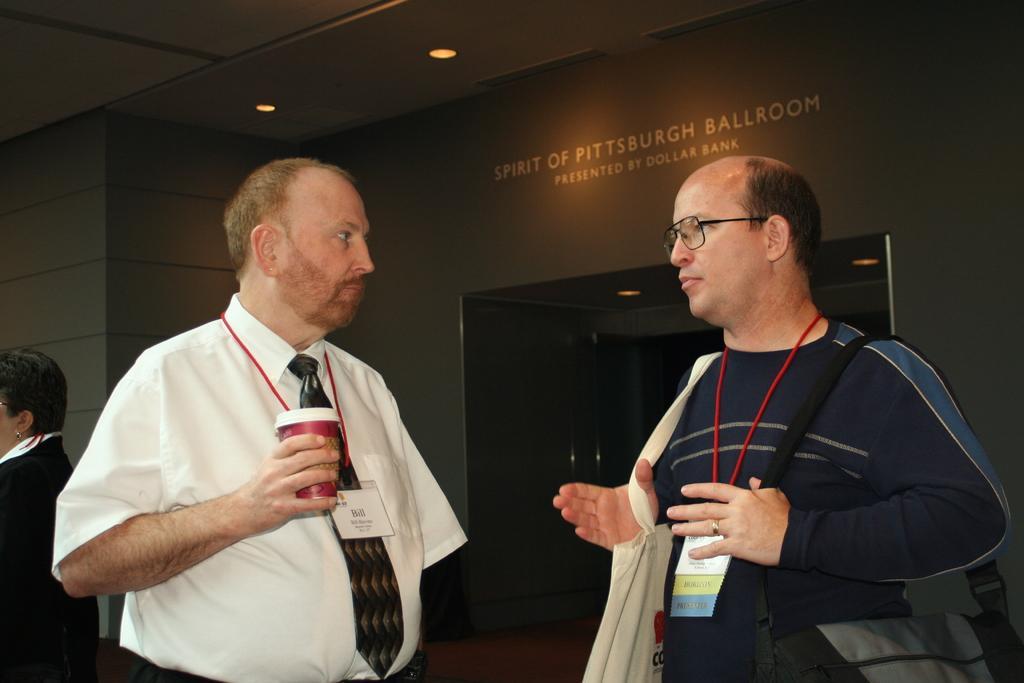Can you describe this image briefly? In this image I can see two men are standing and talking each other. On the left side this man wore shirt, tie and ID card. At the top there are ceiling lights. 